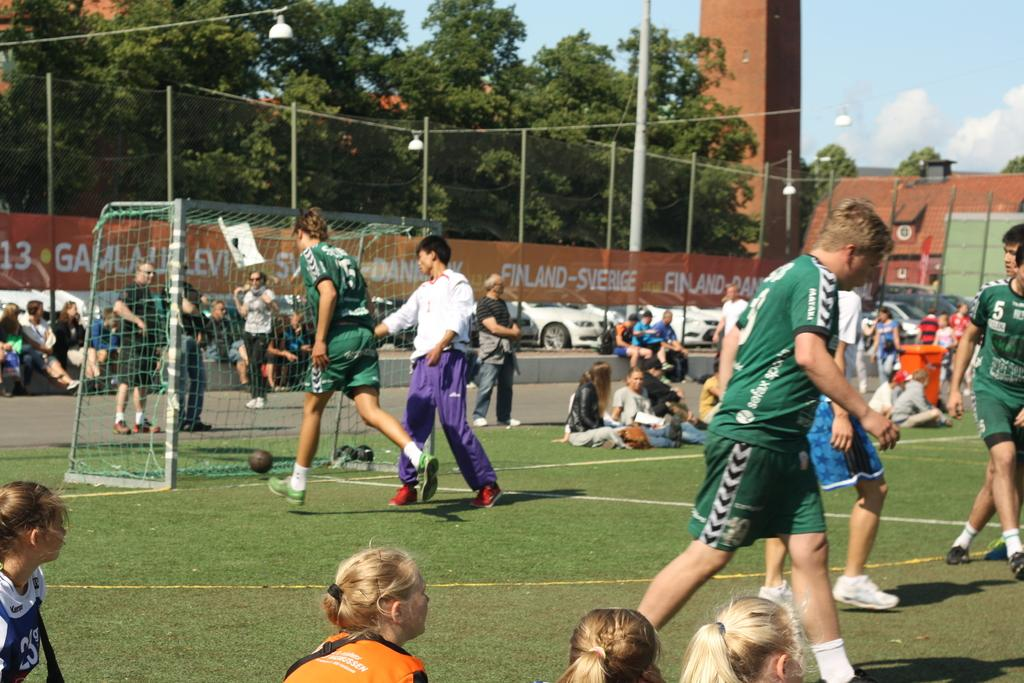<image>
Describe the image concisely. A group of soccer players, one of which wearing the number 5, on a soccer field. 